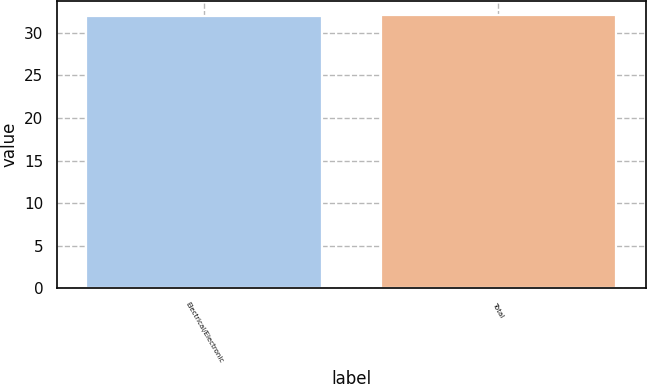<chart> <loc_0><loc_0><loc_500><loc_500><bar_chart><fcel>Electrical/Electronic<fcel>Total<nl><fcel>32<fcel>32.1<nl></chart> 